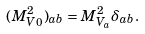Convert formula to latex. <formula><loc_0><loc_0><loc_500><loc_500>( M ^ { 2 } _ { V 0 } ) _ { a b } = M ^ { 2 } _ { V _ { a } } \delta _ { a b } .</formula> 